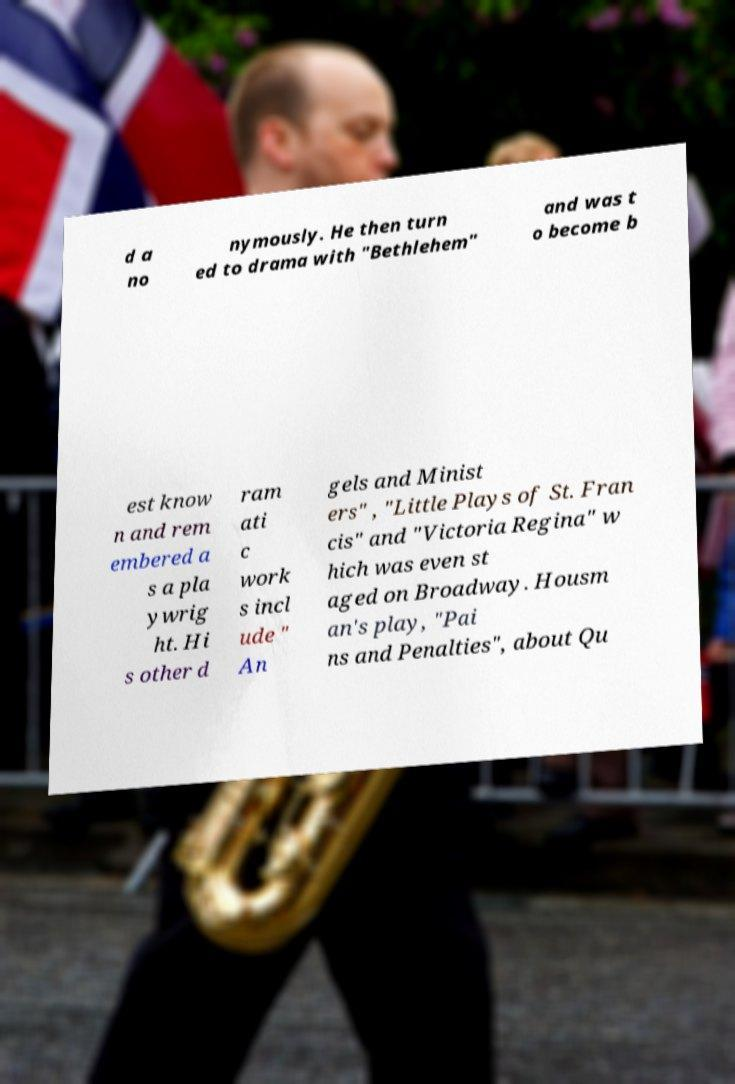Can you accurately transcribe the text from the provided image for me? d a no nymously. He then turn ed to drama with "Bethlehem" and was t o become b est know n and rem embered a s a pla ywrig ht. Hi s other d ram ati c work s incl ude " An gels and Minist ers" , "Little Plays of St. Fran cis" and "Victoria Regina" w hich was even st aged on Broadway. Housm an's play, "Pai ns and Penalties", about Qu 